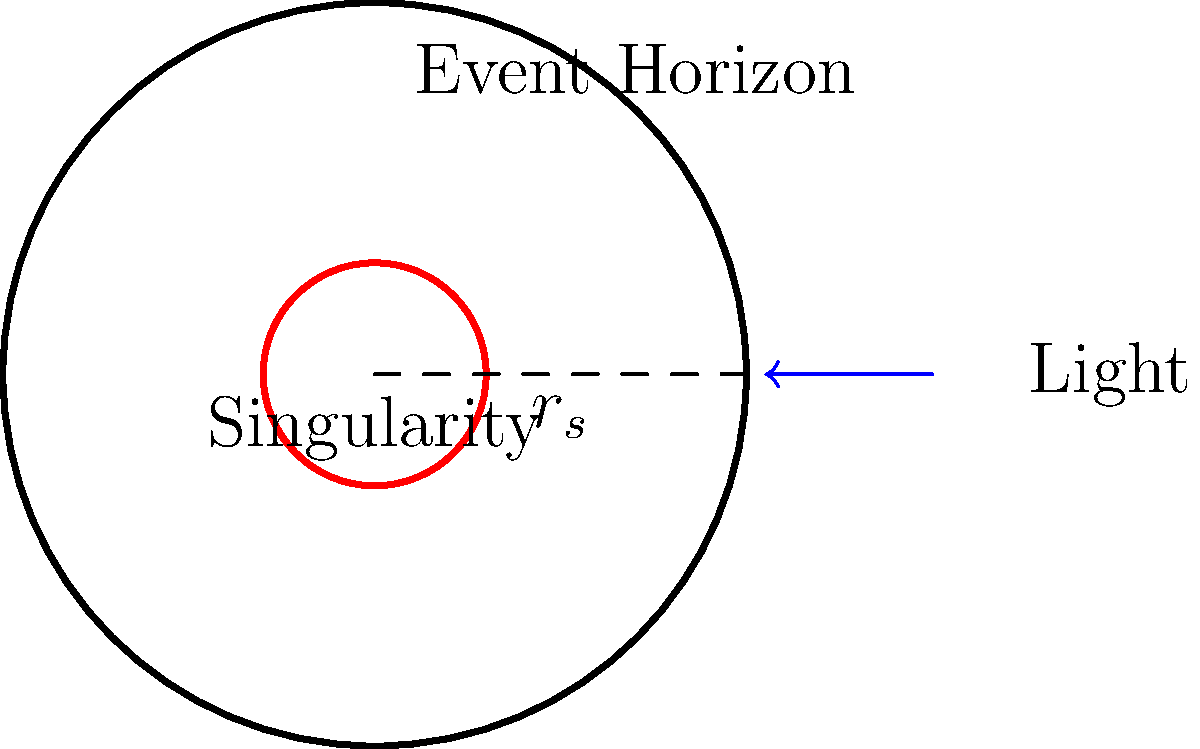As an actor known for your ability to portray diverse characters, imagine you're preparing for a role as an astrophysicist. In a crucial scene, you need to explain the concept of a black hole's event horizon. What is the significance of the Schwarzschild radius ($r_s$) in relation to the event horizon, and how does it affect the behavior of light near a black hole? To answer this question, let's break down the key concepts:

1. Schwarzschild radius ($r_s$):
   The Schwarzschild radius is given by the equation:
   $$r_s = \frac{2GM}{c^2}$$
   Where $G$ is the gravitational constant, $M$ is the mass of the black hole, and $c$ is the speed of light.

2. Event horizon:
   The event horizon is the boundary around a black hole beyond which nothing can escape, not even light. It coincides with the Schwarzschild radius for a non-rotating black hole.

3. Significance of $r_s$:
   a) It defines the point of no return: At $r = r_s$, the escape velocity equals the speed of light.
   b) It determines the size of the black hole: The event horizon's radius is directly proportional to the black hole's mass.

4. Behavior of light near a black hole:
   a) Outside the event horizon ($r > r_s$): Light can still escape, but it experiences gravitational redshift.
   b) At the event horizon ($r = r_s$): Light is trapped, orbiting the black hole indefinitely.
   c) Inside the event horizon ($r < r_s$): Light is inevitably pulled towards the singularity.

5. Gravitational time dilation:
   Time appears to slow down for an outside observer watching an object approach the event horizon, due to the extreme gravitational field.

In the context of acting, understanding these concepts would allow you to convincingly portray an astrophysicist explaining the fundamental properties of black holes and their event horizons.
Answer: The Schwarzschild radius defines the event horizon's location, determining where light can no longer escape the black hole's gravitational pull. 